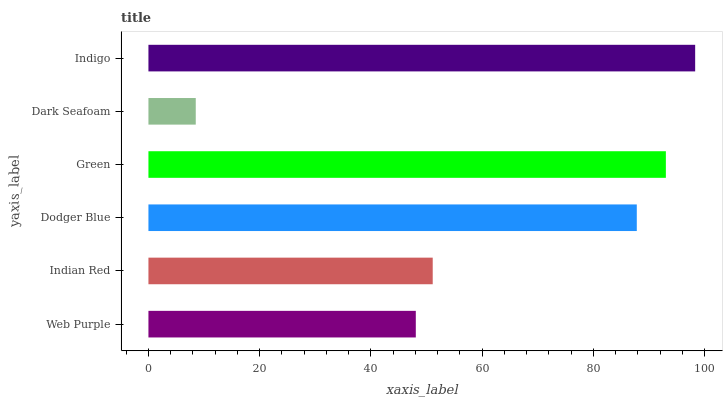Is Dark Seafoam the minimum?
Answer yes or no. Yes. Is Indigo the maximum?
Answer yes or no. Yes. Is Indian Red the minimum?
Answer yes or no. No. Is Indian Red the maximum?
Answer yes or no. No. Is Indian Red greater than Web Purple?
Answer yes or no. Yes. Is Web Purple less than Indian Red?
Answer yes or no. Yes. Is Web Purple greater than Indian Red?
Answer yes or no. No. Is Indian Red less than Web Purple?
Answer yes or no. No. Is Dodger Blue the high median?
Answer yes or no. Yes. Is Indian Red the low median?
Answer yes or no. Yes. Is Dark Seafoam the high median?
Answer yes or no. No. Is Indigo the low median?
Answer yes or no. No. 